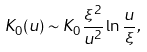Convert formula to latex. <formula><loc_0><loc_0><loc_500><loc_500>K _ { 0 } ( { u } ) \sim K _ { 0 } \frac { \xi ^ { 2 } } { u ^ { 2 } } \ln \frac { u } { \xi } ,</formula> 